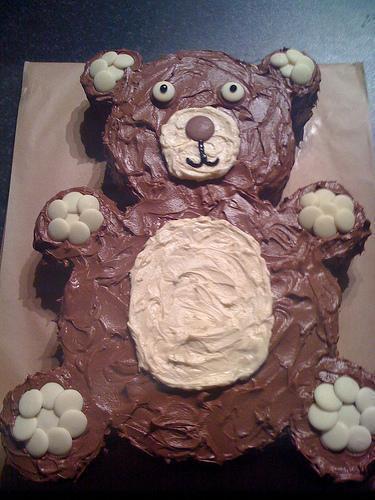How many bears are there?
Give a very brief answer. 1. 